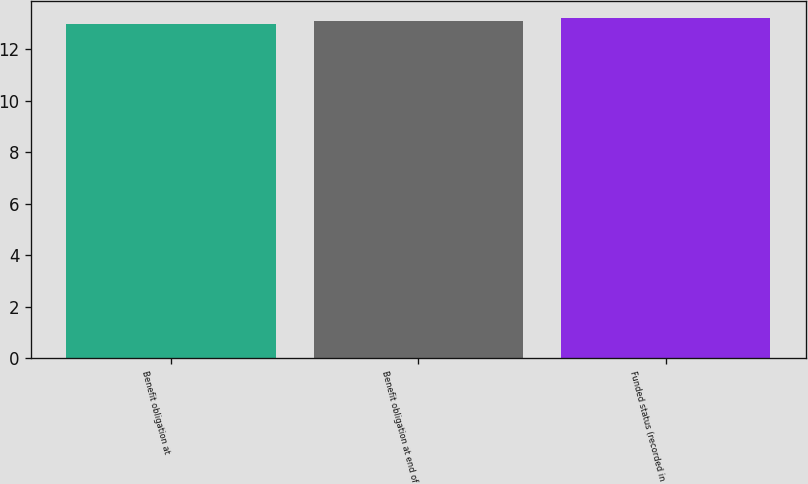Convert chart. <chart><loc_0><loc_0><loc_500><loc_500><bar_chart><fcel>Benefit obligation at<fcel>Benefit obligation at end of<fcel>Funded status (recorded in<nl><fcel>13<fcel>13.1<fcel>13.2<nl></chart> 